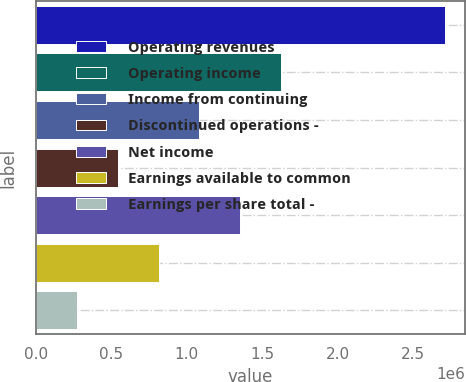Convert chart. <chart><loc_0><loc_0><loc_500><loc_500><bar_chart><fcel>Operating revenues<fcel>Operating income<fcel>Income from continuing<fcel>Discontinued operations -<fcel>Net income<fcel>Earnings available to common<fcel>Earnings per share total -<nl><fcel>2.70757e+06<fcel>1.62454e+06<fcel>1.08303e+06<fcel>541515<fcel>1.35379e+06<fcel>812272<fcel>270758<nl></chart> 